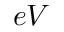<formula> <loc_0><loc_0><loc_500><loc_500>e V</formula> 